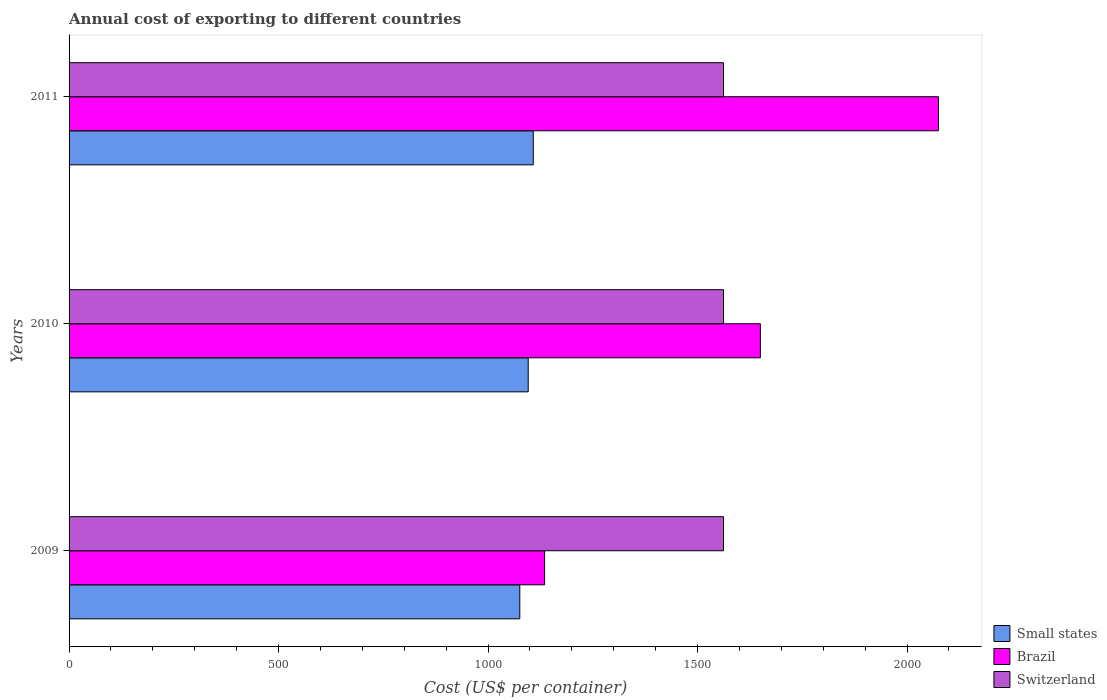How many groups of bars are there?
Offer a terse response. 3. Are the number of bars per tick equal to the number of legend labels?
Give a very brief answer. Yes. Are the number of bars on each tick of the Y-axis equal?
Offer a terse response. Yes. How many bars are there on the 3rd tick from the top?
Your answer should be very brief. 3. In how many cases, is the number of bars for a given year not equal to the number of legend labels?
Keep it short and to the point. 0. What is the total annual cost of exporting in Small states in 2010?
Ensure brevity in your answer.  1095.87. Across all years, what is the maximum total annual cost of exporting in Small states?
Your response must be concise. 1107.92. Across all years, what is the minimum total annual cost of exporting in Switzerland?
Ensure brevity in your answer.  1562. In which year was the total annual cost of exporting in Small states maximum?
Provide a succinct answer. 2011. In which year was the total annual cost of exporting in Brazil minimum?
Give a very brief answer. 2009. What is the total total annual cost of exporting in Switzerland in the graph?
Give a very brief answer. 4686. What is the difference between the total annual cost of exporting in Small states in 2009 and that in 2010?
Give a very brief answer. -20.08. What is the difference between the total annual cost of exporting in Small states in 2010 and the total annual cost of exporting in Brazil in 2011?
Offer a very short reply. -979.13. What is the average total annual cost of exporting in Brazil per year?
Provide a short and direct response. 1620. In the year 2010, what is the difference between the total annual cost of exporting in Brazil and total annual cost of exporting in Switzerland?
Your answer should be very brief. 88. What is the ratio of the total annual cost of exporting in Small states in 2009 to that in 2011?
Provide a short and direct response. 0.97. Is the total annual cost of exporting in Brazil in 2009 less than that in 2011?
Your answer should be compact. Yes. What is the difference between the highest and the second highest total annual cost of exporting in Small states?
Your response must be concise. 12.05. What is the difference between the highest and the lowest total annual cost of exporting in Brazil?
Provide a succinct answer. 940. Is the sum of the total annual cost of exporting in Switzerland in 2009 and 2010 greater than the maximum total annual cost of exporting in Brazil across all years?
Provide a succinct answer. Yes. Is it the case that in every year, the sum of the total annual cost of exporting in Small states and total annual cost of exporting in Switzerland is greater than the total annual cost of exporting in Brazil?
Your answer should be very brief. Yes. How many bars are there?
Provide a succinct answer. 9. Are all the bars in the graph horizontal?
Offer a very short reply. Yes. How many years are there in the graph?
Provide a short and direct response. 3. What is the difference between two consecutive major ticks on the X-axis?
Keep it short and to the point. 500. Are the values on the major ticks of X-axis written in scientific E-notation?
Provide a succinct answer. No. Where does the legend appear in the graph?
Give a very brief answer. Bottom right. How many legend labels are there?
Your answer should be very brief. 3. What is the title of the graph?
Your response must be concise. Annual cost of exporting to different countries. What is the label or title of the X-axis?
Make the answer very short. Cost (US$ per container). What is the Cost (US$ per container) in Small states in 2009?
Offer a very short reply. 1075.79. What is the Cost (US$ per container) of Brazil in 2009?
Make the answer very short. 1135. What is the Cost (US$ per container) in Switzerland in 2009?
Your response must be concise. 1562. What is the Cost (US$ per container) of Small states in 2010?
Provide a short and direct response. 1095.87. What is the Cost (US$ per container) in Brazil in 2010?
Give a very brief answer. 1650. What is the Cost (US$ per container) in Switzerland in 2010?
Ensure brevity in your answer.  1562. What is the Cost (US$ per container) of Small states in 2011?
Provide a short and direct response. 1107.92. What is the Cost (US$ per container) in Brazil in 2011?
Offer a very short reply. 2075. What is the Cost (US$ per container) in Switzerland in 2011?
Offer a terse response. 1562. Across all years, what is the maximum Cost (US$ per container) of Small states?
Provide a succinct answer. 1107.92. Across all years, what is the maximum Cost (US$ per container) in Brazil?
Offer a very short reply. 2075. Across all years, what is the maximum Cost (US$ per container) in Switzerland?
Keep it short and to the point. 1562. Across all years, what is the minimum Cost (US$ per container) in Small states?
Offer a very short reply. 1075.79. Across all years, what is the minimum Cost (US$ per container) in Brazil?
Your response must be concise. 1135. Across all years, what is the minimum Cost (US$ per container) in Switzerland?
Give a very brief answer. 1562. What is the total Cost (US$ per container) of Small states in the graph?
Provide a short and direct response. 3279.59. What is the total Cost (US$ per container) in Brazil in the graph?
Make the answer very short. 4860. What is the total Cost (US$ per container) in Switzerland in the graph?
Keep it short and to the point. 4686. What is the difference between the Cost (US$ per container) of Small states in 2009 and that in 2010?
Make the answer very short. -20.08. What is the difference between the Cost (US$ per container) of Brazil in 2009 and that in 2010?
Make the answer very short. -515. What is the difference between the Cost (US$ per container) in Small states in 2009 and that in 2011?
Provide a succinct answer. -32.13. What is the difference between the Cost (US$ per container) in Brazil in 2009 and that in 2011?
Provide a succinct answer. -940. What is the difference between the Cost (US$ per container) of Small states in 2010 and that in 2011?
Provide a short and direct response. -12.05. What is the difference between the Cost (US$ per container) in Brazil in 2010 and that in 2011?
Your answer should be compact. -425. What is the difference between the Cost (US$ per container) of Switzerland in 2010 and that in 2011?
Provide a succinct answer. 0. What is the difference between the Cost (US$ per container) in Small states in 2009 and the Cost (US$ per container) in Brazil in 2010?
Your response must be concise. -574.21. What is the difference between the Cost (US$ per container) in Small states in 2009 and the Cost (US$ per container) in Switzerland in 2010?
Your response must be concise. -486.21. What is the difference between the Cost (US$ per container) in Brazil in 2009 and the Cost (US$ per container) in Switzerland in 2010?
Your response must be concise. -427. What is the difference between the Cost (US$ per container) of Small states in 2009 and the Cost (US$ per container) of Brazil in 2011?
Keep it short and to the point. -999.21. What is the difference between the Cost (US$ per container) of Small states in 2009 and the Cost (US$ per container) of Switzerland in 2011?
Offer a very short reply. -486.21. What is the difference between the Cost (US$ per container) of Brazil in 2009 and the Cost (US$ per container) of Switzerland in 2011?
Offer a terse response. -427. What is the difference between the Cost (US$ per container) of Small states in 2010 and the Cost (US$ per container) of Brazil in 2011?
Your answer should be compact. -979.13. What is the difference between the Cost (US$ per container) in Small states in 2010 and the Cost (US$ per container) in Switzerland in 2011?
Offer a very short reply. -466.13. What is the difference between the Cost (US$ per container) in Brazil in 2010 and the Cost (US$ per container) in Switzerland in 2011?
Provide a succinct answer. 88. What is the average Cost (US$ per container) of Small states per year?
Your answer should be compact. 1093.2. What is the average Cost (US$ per container) of Brazil per year?
Provide a succinct answer. 1620. What is the average Cost (US$ per container) of Switzerland per year?
Offer a very short reply. 1562. In the year 2009, what is the difference between the Cost (US$ per container) in Small states and Cost (US$ per container) in Brazil?
Give a very brief answer. -59.21. In the year 2009, what is the difference between the Cost (US$ per container) in Small states and Cost (US$ per container) in Switzerland?
Keep it short and to the point. -486.21. In the year 2009, what is the difference between the Cost (US$ per container) of Brazil and Cost (US$ per container) of Switzerland?
Provide a succinct answer. -427. In the year 2010, what is the difference between the Cost (US$ per container) of Small states and Cost (US$ per container) of Brazil?
Your answer should be compact. -554.13. In the year 2010, what is the difference between the Cost (US$ per container) in Small states and Cost (US$ per container) in Switzerland?
Ensure brevity in your answer.  -466.13. In the year 2011, what is the difference between the Cost (US$ per container) in Small states and Cost (US$ per container) in Brazil?
Your answer should be compact. -967.08. In the year 2011, what is the difference between the Cost (US$ per container) of Small states and Cost (US$ per container) of Switzerland?
Provide a short and direct response. -454.07. In the year 2011, what is the difference between the Cost (US$ per container) in Brazil and Cost (US$ per container) in Switzerland?
Offer a very short reply. 513. What is the ratio of the Cost (US$ per container) in Small states in 2009 to that in 2010?
Your answer should be very brief. 0.98. What is the ratio of the Cost (US$ per container) in Brazil in 2009 to that in 2010?
Keep it short and to the point. 0.69. What is the ratio of the Cost (US$ per container) of Switzerland in 2009 to that in 2010?
Your answer should be very brief. 1. What is the ratio of the Cost (US$ per container) of Small states in 2009 to that in 2011?
Provide a short and direct response. 0.97. What is the ratio of the Cost (US$ per container) in Brazil in 2009 to that in 2011?
Your answer should be compact. 0.55. What is the ratio of the Cost (US$ per container) of Small states in 2010 to that in 2011?
Keep it short and to the point. 0.99. What is the ratio of the Cost (US$ per container) in Brazil in 2010 to that in 2011?
Make the answer very short. 0.8. What is the ratio of the Cost (US$ per container) of Switzerland in 2010 to that in 2011?
Make the answer very short. 1. What is the difference between the highest and the second highest Cost (US$ per container) in Small states?
Provide a succinct answer. 12.05. What is the difference between the highest and the second highest Cost (US$ per container) of Brazil?
Your answer should be compact. 425. What is the difference between the highest and the lowest Cost (US$ per container) of Small states?
Provide a short and direct response. 32.13. What is the difference between the highest and the lowest Cost (US$ per container) in Brazil?
Offer a terse response. 940. 